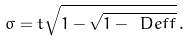<formula> <loc_0><loc_0><loc_500><loc_500>\sigma = t \sqrt { 1 - \sqrt { 1 - \ D e f f } } \, .</formula> 